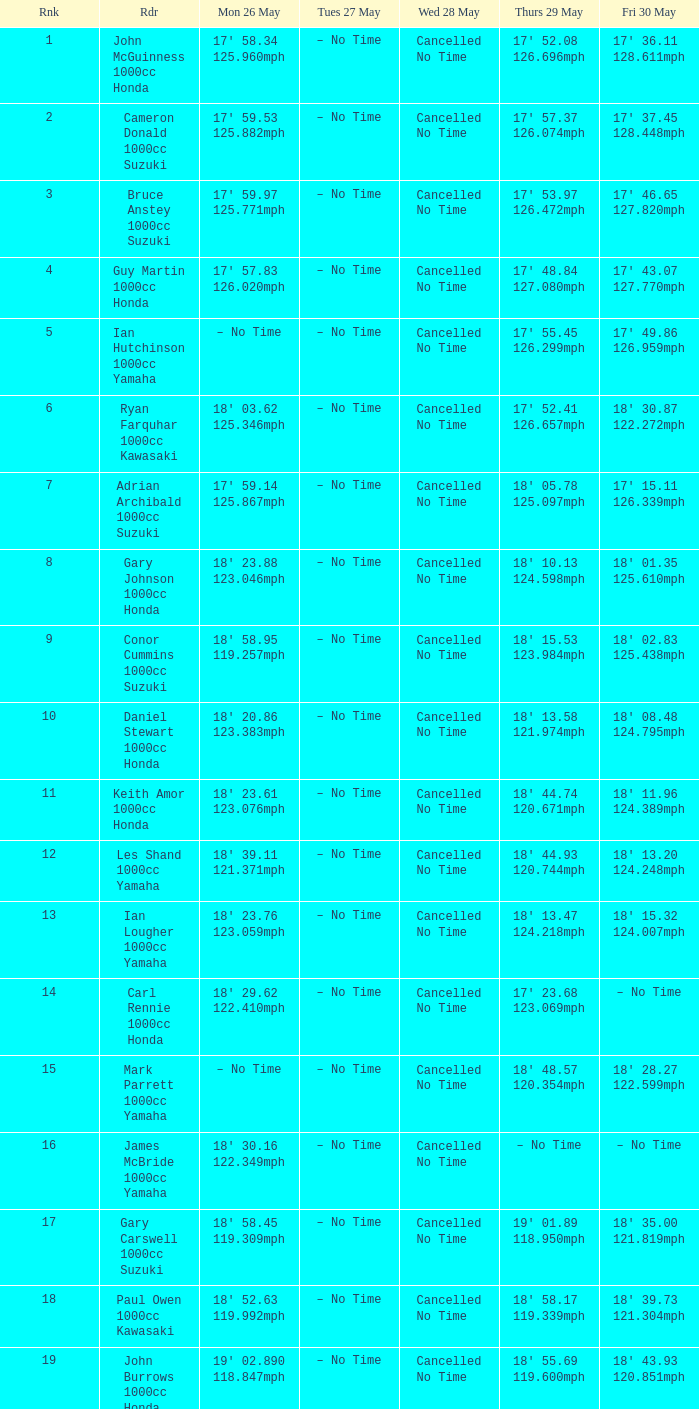When taking into account the measurements 19' 02.890 and 118.847 mph, what is the number related to friday, may 30, and monday, may 26? 18' 43.93 120.851mph. 